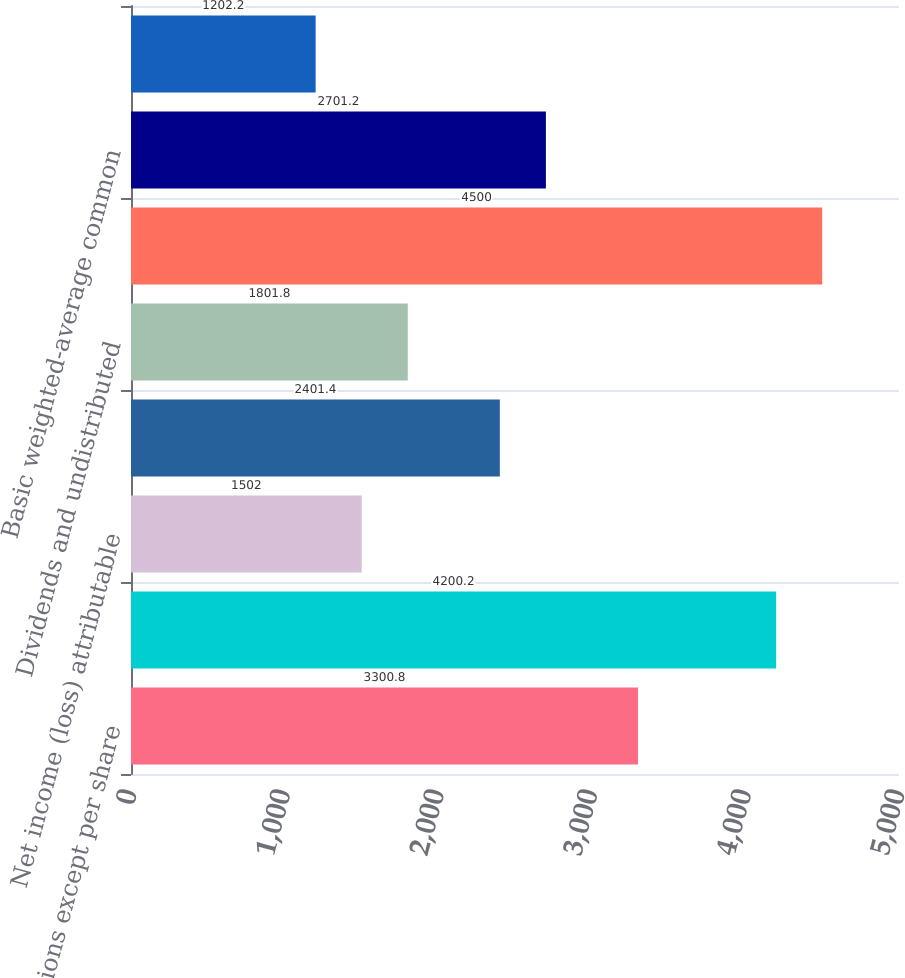Convert chart. <chart><loc_0><loc_0><loc_500><loc_500><bar_chart><fcel>In millions except per share<fcel>Net income from continuing<fcel>Net income (loss) attributable<fcel>Preferred stock dividends and<fcel>Dividends and undistributed<fcel>Net income attributable to<fcel>Basic weighted-average common<fcel>Basic earnings per common<nl><fcel>3300.8<fcel>4200.2<fcel>1502<fcel>2401.4<fcel>1801.8<fcel>4500<fcel>2701.2<fcel>1202.2<nl></chart> 